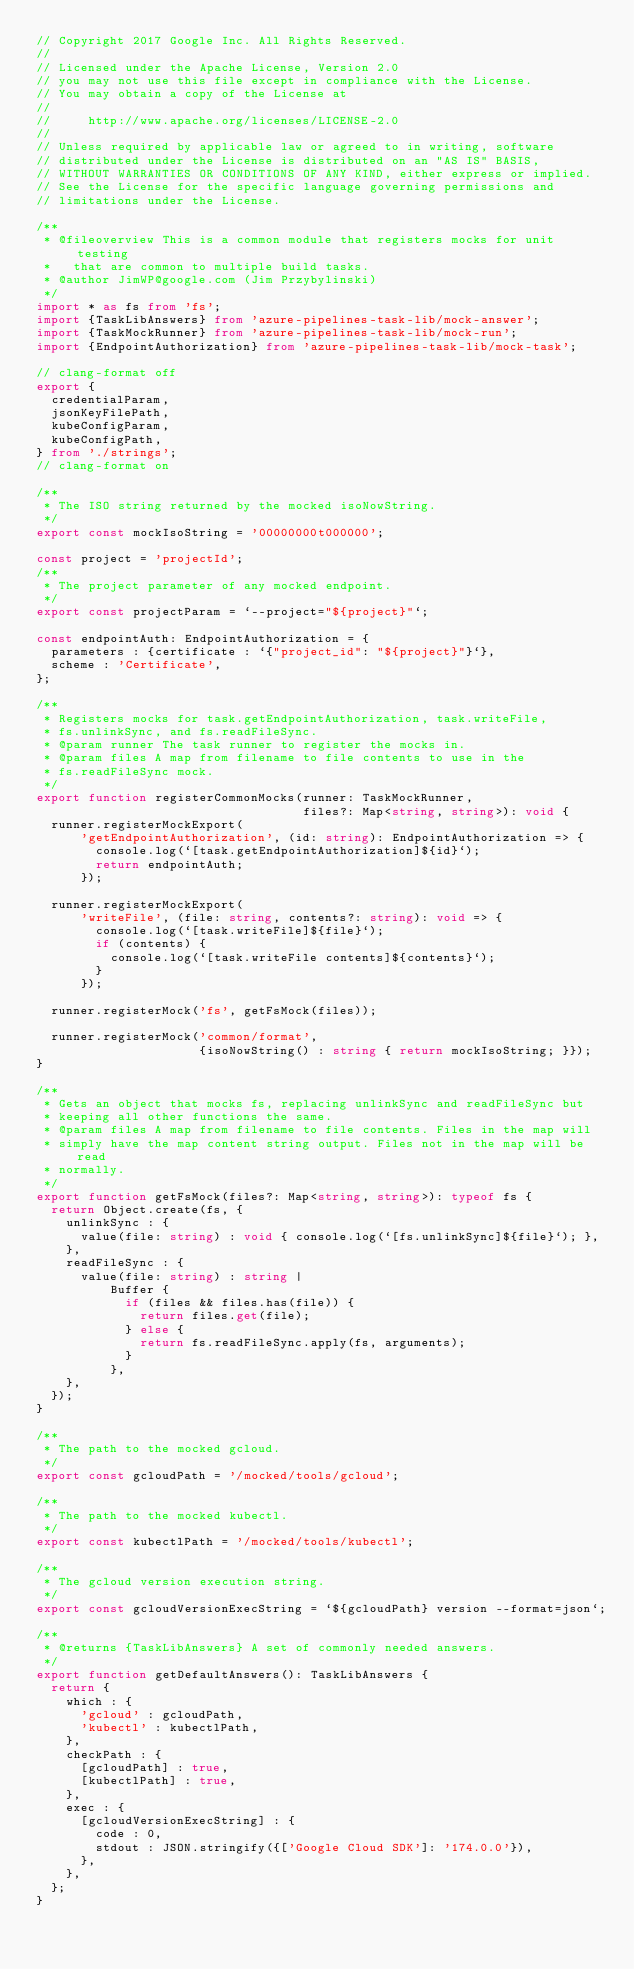<code> <loc_0><loc_0><loc_500><loc_500><_TypeScript_>// Copyright 2017 Google Inc. All Rights Reserved.
//
// Licensed under the Apache License, Version 2.0
// you may not use this file except in compliance with the License.
// You may obtain a copy of the License at
//
//     http://www.apache.org/licenses/LICENSE-2.0
//
// Unless required by applicable law or agreed to in writing, software
// distributed under the License is distributed on an "AS IS" BASIS,
// WITHOUT WARRANTIES OR CONDITIONS OF ANY KIND, either express or implied.
// See the License for the specific language governing permissions and
// limitations under the License.

/**
 * @fileoverview This is a common module that registers mocks for unit testing
 *   that are common to multiple build tasks.
 * @author JimWP@google.com (Jim Przybylinski)
 */
import * as fs from 'fs';
import {TaskLibAnswers} from 'azure-pipelines-task-lib/mock-answer';
import {TaskMockRunner} from 'azure-pipelines-task-lib/mock-run';
import {EndpointAuthorization} from 'azure-pipelines-task-lib/mock-task';

// clang-format off
export {
  credentialParam,
  jsonKeyFilePath,
  kubeConfigParam,
  kubeConfigPath,
} from './strings';
// clang-format on

/**
 * The ISO string returned by the mocked isoNowString.
 */
export const mockIsoString = '00000000t000000';

const project = 'projectId';
/**
 * The project parameter of any mocked endpoint.
 */
export const projectParam = `--project="${project}"`;

const endpointAuth: EndpointAuthorization = {
  parameters : {certificate : `{"project_id": "${project}"}`},
  scheme : 'Certificate',
};

/**
 * Registers mocks for task.getEndpointAuthorization, task.writeFile,
 * fs.unlinkSync, and fs.readFileSync.
 * @param runner The task runner to register the mocks in.
 * @param files A map from filename to file contents to use in the
 * fs.readFileSync mock.
 */
export function registerCommonMocks(runner: TaskMockRunner,
                                    files?: Map<string, string>): void {
  runner.registerMockExport(
      'getEndpointAuthorization', (id: string): EndpointAuthorization => {
        console.log(`[task.getEndpointAuthorization]${id}`);
        return endpointAuth;
      });

  runner.registerMockExport(
      'writeFile', (file: string, contents?: string): void => {
        console.log(`[task.writeFile]${file}`);
        if (contents) {
          console.log(`[task.writeFile contents]${contents}`);
        }
      });

  runner.registerMock('fs', getFsMock(files));

  runner.registerMock('common/format',
                      {isoNowString() : string { return mockIsoString; }});
}

/**
 * Gets an object that mocks fs, replacing unlinkSync and readFileSync but
 * keeping all other functions the same.
 * @param files A map from filename to file contents. Files in the map will
 * simply have the map content string output. Files not in the map will be read
 * normally.
 */
export function getFsMock(files?: Map<string, string>): typeof fs {
  return Object.create(fs, {
    unlinkSync : {
      value(file: string) : void { console.log(`[fs.unlinkSync]${file}`); },
    },
    readFileSync : {
      value(file: string) : string |
          Buffer {
            if (files && files.has(file)) {
              return files.get(file);
            } else {
              return fs.readFileSync.apply(fs, arguments);
            }
          },
    },
  });
}

/**
 * The path to the mocked gcloud.
 */
export const gcloudPath = '/mocked/tools/gcloud';

/**
 * The path to the mocked kubectl.
 */
export const kubectlPath = '/mocked/tools/kubectl';

/**
 * The gcloud version execution string.
 */
export const gcloudVersionExecString = `${gcloudPath} version --format=json`;

/**
 * @returns {TaskLibAnswers} A set of commonly needed answers.
 */
export function getDefaultAnswers(): TaskLibAnswers {
  return {
    which : {
      'gcloud' : gcloudPath,
      'kubectl' : kubectlPath,
    },
    checkPath : {
      [gcloudPath] : true,
      [kubectlPath] : true,
    },
    exec : {
      [gcloudVersionExecString] : {
        code : 0,
        stdout : JSON.stringify({['Google Cloud SDK']: '174.0.0'}),
      },
    },
  };
}
</code> 